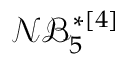<formula> <loc_0><loc_0><loc_500><loc_500>\mathcal { N B } _ { 5 } ^ { * [ 4 ] }</formula> 